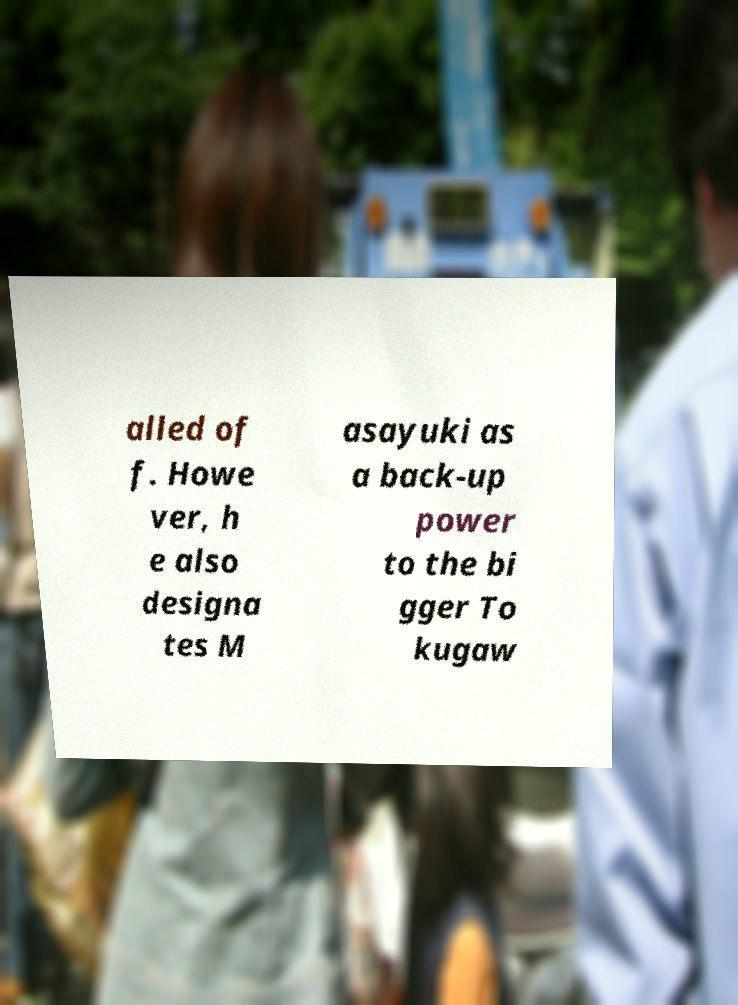Please identify and transcribe the text found in this image. alled of f. Howe ver, h e also designa tes M asayuki as a back-up power to the bi gger To kugaw 